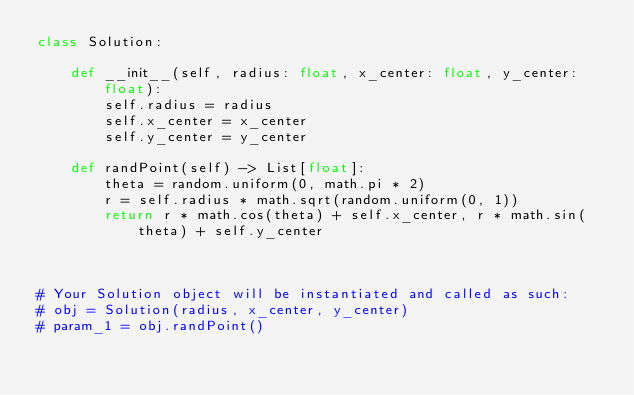Convert code to text. <code><loc_0><loc_0><loc_500><loc_500><_Python_>class Solution:

    def __init__(self, radius: float, x_center: float, y_center: float):
        self.radius = radius
        self.x_center = x_center
        self.y_center = y_center
        
    def randPoint(self) -> List[float]:
        theta = random.uniform(0, math.pi * 2)
        r = self.radius * math.sqrt(random.uniform(0, 1))
        return r * math.cos(theta) + self.x_center, r * math.sin(theta) + self.y_center
        


# Your Solution object will be instantiated and called as such:
# obj = Solution(radius, x_center, y_center)
# param_1 = obj.randPoint()
</code> 